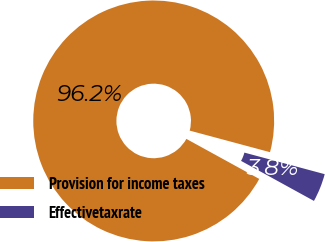Convert chart to OTSL. <chart><loc_0><loc_0><loc_500><loc_500><pie_chart><fcel>Provision for income taxes<fcel>Effectivetaxrate<nl><fcel>96.18%<fcel>3.82%<nl></chart> 